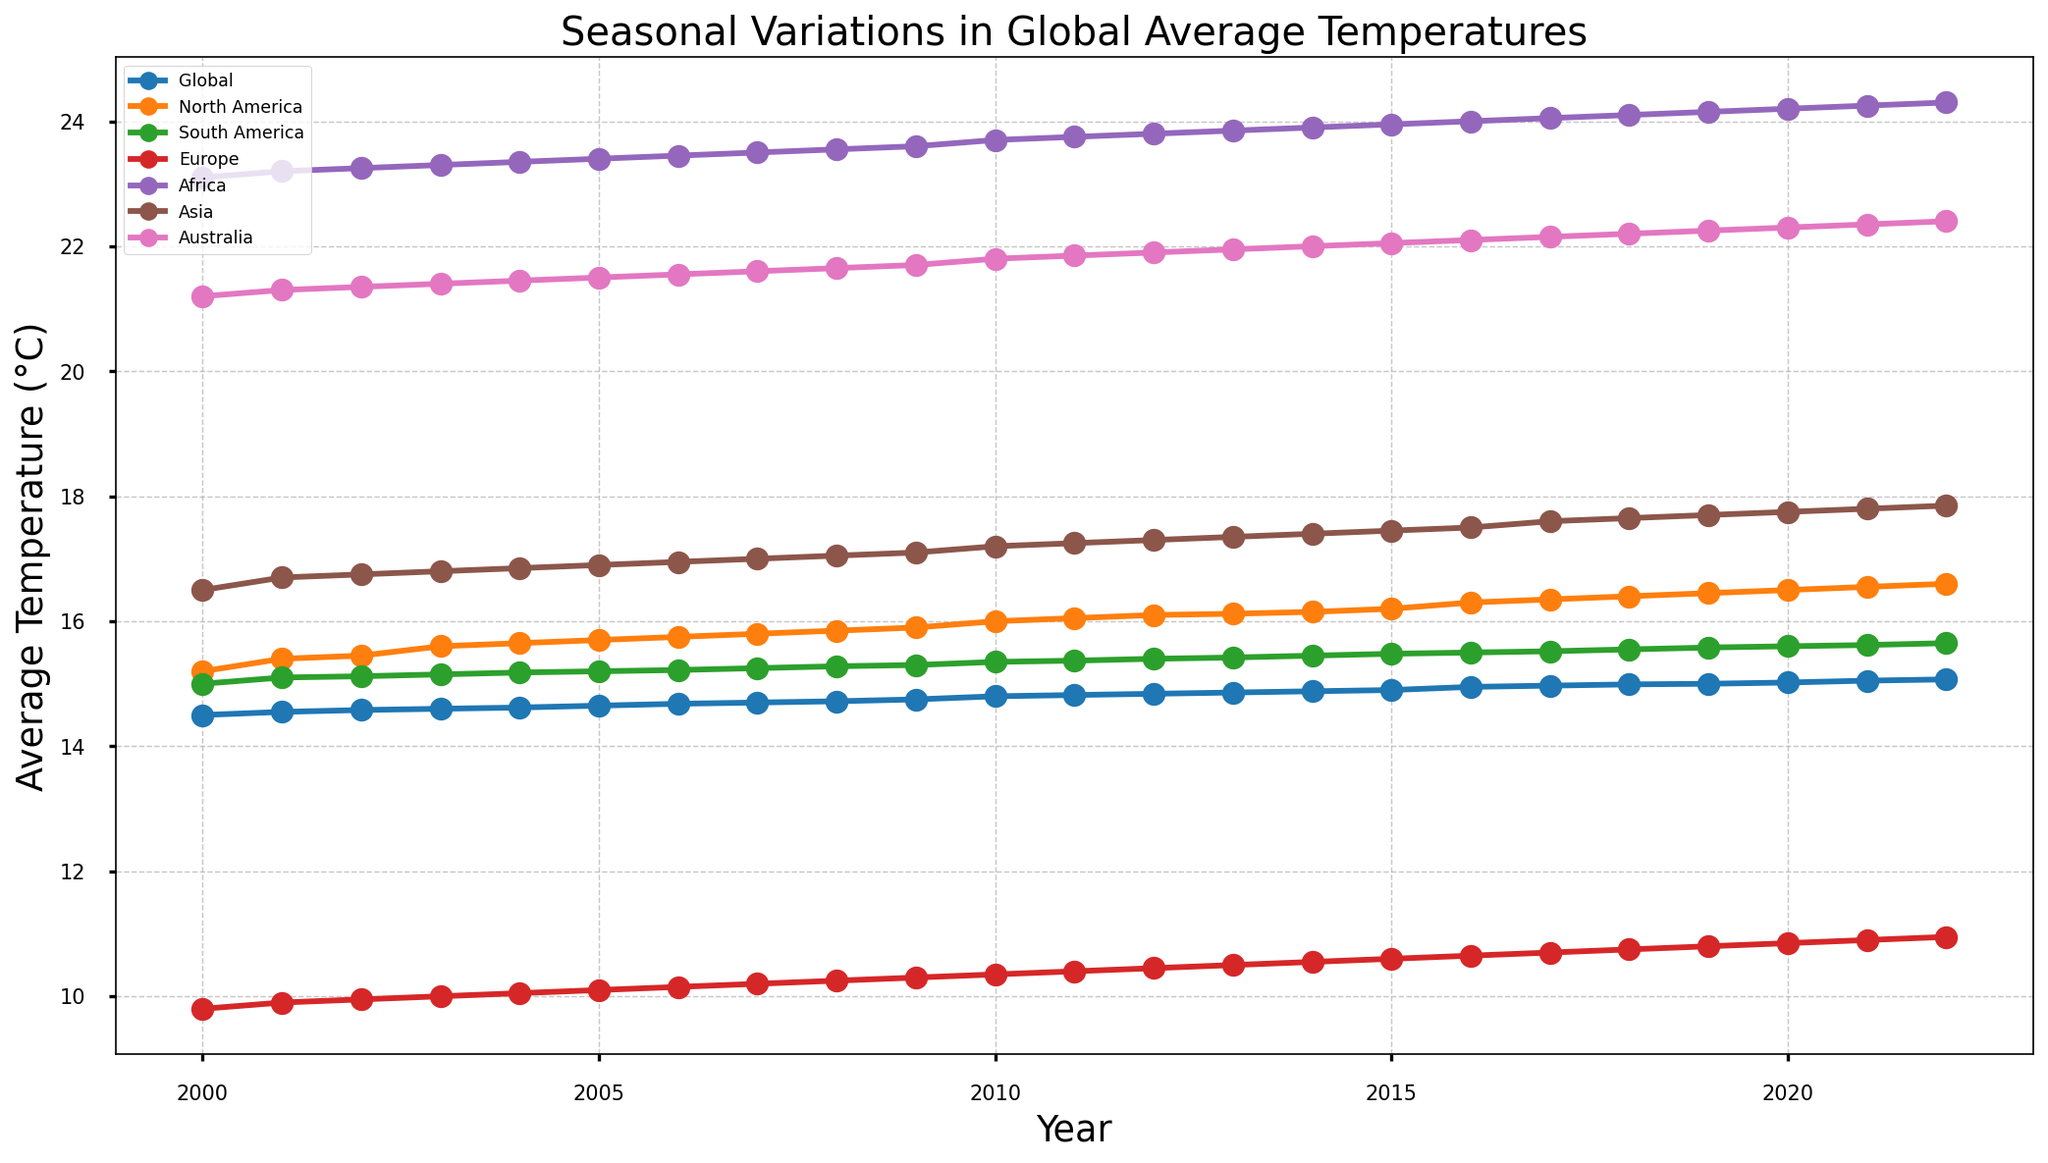What trend can you observe for the global average temperature from 2000 to 2022? The global average temperature shows a consistent upward trend from 2000 to 2022. The plot indicates a steady increase from approximately 14.50°C in 2000 to around 15.07°C in 2022. This trend can be observed by following the global line, which rises steadily over the years.
Answer: Increasing Which continent experienced the highest increase in average temperature from 2000 to 2022? To determine the highest increase, compare the temperature differences for each continent between 2000 and 2022. Africa shows the largest increase from approximately 23.10°C in 2000 to 24.30°C in 2022. The change is 1.20°C, which is the highest compared to other continents.
Answer: Africa In which year did North America’s average temperature first exceed 16.00°C? To find the year when North America's temperature first exceeded 16.00°C, follow the North America line on the plot. The temperature first crosses 16.00°C in 2010, as it reaches 16.00°C that year and continues to rise afterward.
Answer: 2010 Compare the slopes of the trend lines for Europe and Australia. In which region was the increase more pronounced? Compare the slopes by noting the start and end points. Europe's temperature starts around 9.80°C in 2000 and ends at 10.95°C in 2022 (an increase of 1.15°C). Australia's temperature starts around 21.20°C in 2000 and ends at 22.40°C in 2022 (an increase of 1.20°C). Australia has a slightly more pronounced increase.
Answer: Australia What is the difference in average temperature between Asia and South America in the year 2022? Look at the 2022 data points for Asia and South America. Asia's temperature is 17.85°C and South America's is 15.65°C. The difference is calculated as 17.85 - 15.65 = 2.20°C.
Answer: 2.20°C How does the average temperature trend for North America compare to the global trend? Both North America and the global lines show a consistent increase over the years. However, the slope for North America is steeper. North America increases from approximately 15.20°C to 16.60°C, while the global temperature increases from 14.50°C to 15.07°C over the same period. Thus, North America exhibits a steeper and higher increase compared to the global average.
Answer: Steeper increase Which continent had the least variation in its average temperature between 2000 and 2022? To find the continent with the least variation, observe the temperature range for each continent over the years. South America shows the least variation, fluctuating between approximately 15.00°C and 15.65°C, a difference of 0.65°C, which is less than the variations observed in other continents.
Answer: South America Find the average temperature of Africa over the first five years (2000-2004). Sum the temperatures for Africa from 2000 to 2004: 23.10, 23.20, 23.25, 23.30, and 23.35. Adding these gives 116.20. Divide by 5 to find the average: 116.20 / 5 = 23.24°C.
Answer: 23.24°C Was there any year where Australia had a lower average temperature than in 2000? Follow the Australia temperature line and compare each value with the 2000 temperature of 21.20°C. No data point falls below 21.20°C after 2000, indicating that Australia's average temperature remained above the 2000 level throughout the years.
Answer: No 